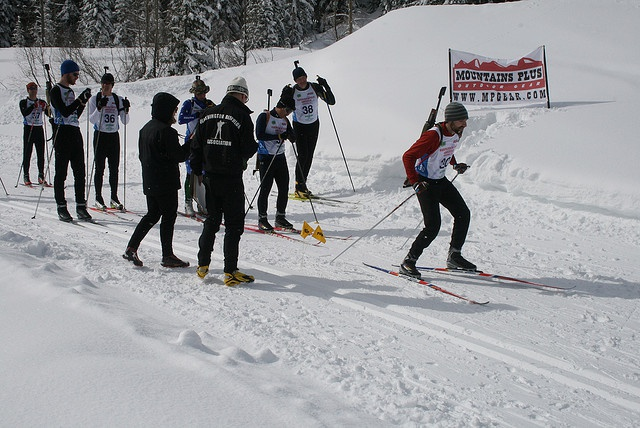Describe the objects in this image and their specific colors. I can see people in black, gray, darkgray, and olive tones, people in black, lightgray, darkgray, and gray tones, people in black, maroon, gray, and darkgray tones, people in black, gray, darkgray, and lightgray tones, and people in black, gray, darkgray, and lightgray tones in this image. 